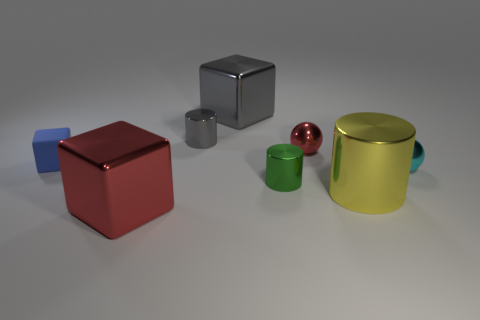Subtract all green metal cylinders. How many cylinders are left? 2 Subtract all cyan balls. How many balls are left? 1 Add 1 red rubber balls. How many objects exist? 9 Subtract all cubes. How many objects are left? 5 Subtract all large cylinders. Subtract all gray cylinders. How many objects are left? 6 Add 2 tiny metallic balls. How many tiny metallic balls are left? 4 Add 6 small blocks. How many small blocks exist? 7 Subtract 0 green balls. How many objects are left? 8 Subtract 3 cylinders. How many cylinders are left? 0 Subtract all purple cylinders. Subtract all green cubes. How many cylinders are left? 3 